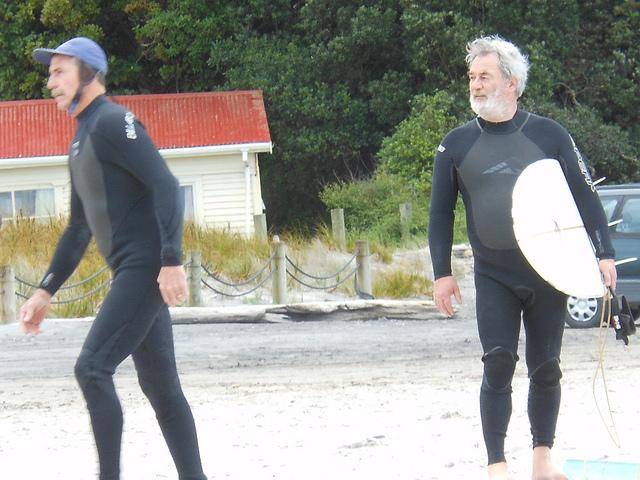Where do these men want to go next?

Choices:
A) cafe
B) bed
C) home
D) ocean ocean 